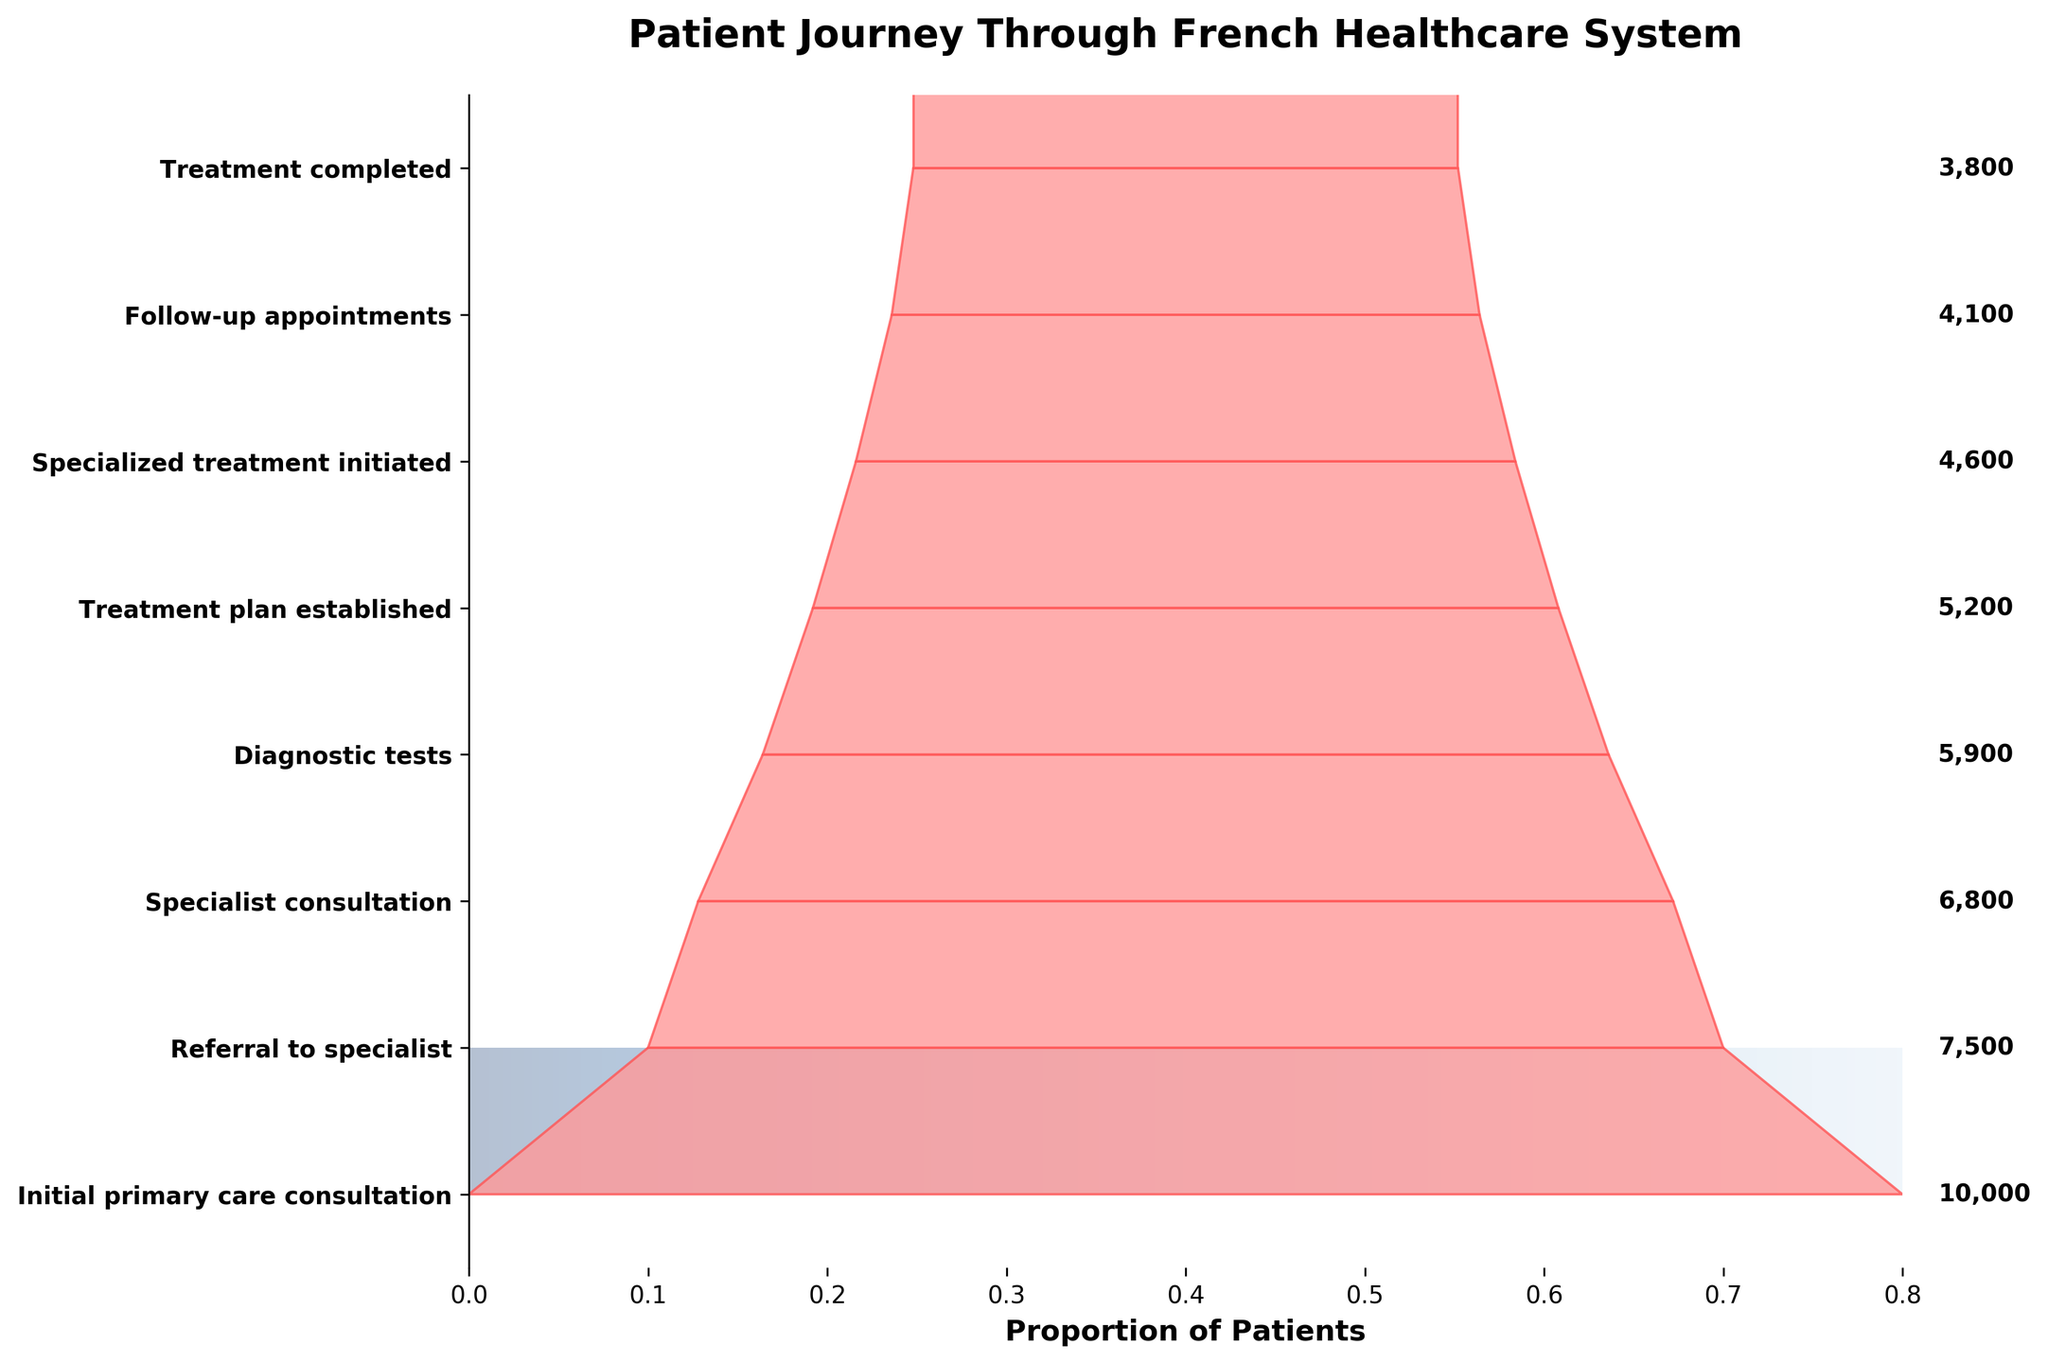What is the title of the funnel chart? The title is shown at the top of the chart. It summarizes the subject of the chart.
Answer: Patient Journey Through French Healthcare System How many patients started the initial primary care consultation? According to the chart, the number beside the bar for "Initial primary care consultation" indicates the number of patients.
Answer: 10,000 What is the percentage drop from "Initial primary care consultation" to "Referral to specialist"? Calculate the drop by subtracting the number of patients at "Referral to specialist" from those at "Initial primary care consultation". Then, divide the result by the initial number and multiply by 100 to get the percentage. (10,000 - 7,500) / 10,000 * 100
Answer: 25% How many more patients were referred to a specialist than those who completed their treatment? Subtract the number of patients at "Treatment completed" from those at "Referral to specialist". 7,500 - 3,800
Answer: 3,700 Which step has the smallest patient drop compared to the previous step? Compare the drop between each consecutive step by subtracting the patient numbers. The smallest drop will be where the difference is the least. 7,500 - 6,800 = 700; 6,800 - 5,900 = 900; 5,900 - 5,200 = 700; 5,200 - 4,600 = 600; 4,600 - 4,100 = 500; 4,100 - 3,800 = 300.
Answer: Treatment completed What is the total number of patients involved in the "Specialized treatment initiated" and "Follow-up appointments" stages? Add the number of patients at "Specialized treatment initiated" and "Follow-up appointments". 4,600 + 4,100
Answer: 8,700 Which step shows the highest patient attrition rate in comparison to the previous step? Determine the step where the difference in patient numbers is the greatest compared to the previous step. Compare each drop: 10,000 - 7,500 = 2,500; 7,500 - 6,800 = 700; 6,800 - 5,900 = 900; 5,900 - 5,200 = 700; 5,200 - 4,600 = 600; 4,600 - 4,100 = 500; 4,100 - 3,800 = 300.
Answer: Initial primary care consultation to Referral to specialist What is the average number of patients from "Diagnostic tests" to "Treatment completed"? Calculate the average number of patients over the mentioned steps. Add the patients for each step and divide by the number of steps: (5,900 + 5,200 + 4,600 + 4,100 + 3,800) / 5.
Answer: 4,720 How many steps are present in the patient journey as depicted in the funnel chart? Simply count the number of steps listed on the y-axis.
Answer: 8 